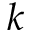Convert formula to latex. <formula><loc_0><loc_0><loc_500><loc_500>k</formula> 